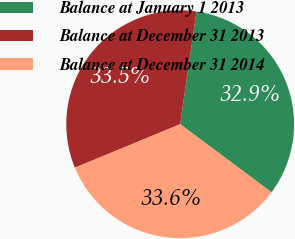<chart> <loc_0><loc_0><loc_500><loc_500><pie_chart><fcel>Balance at January 1 2013<fcel>Balance at December 31 2013<fcel>Balance at December 31 2014<nl><fcel>32.9%<fcel>33.52%<fcel>33.58%<nl></chart> 